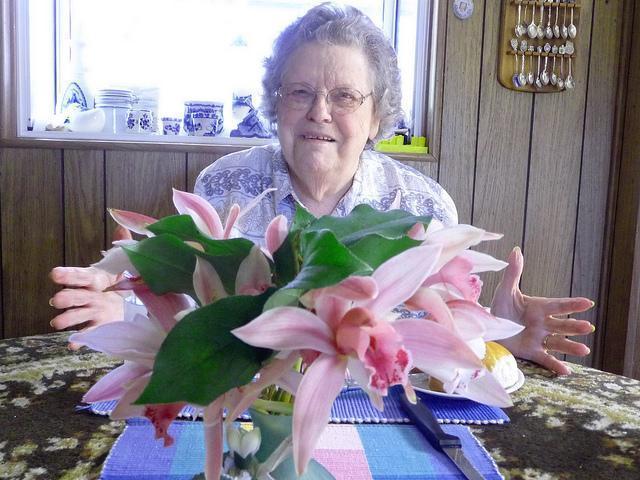How many laptops are there?
Give a very brief answer. 0. 